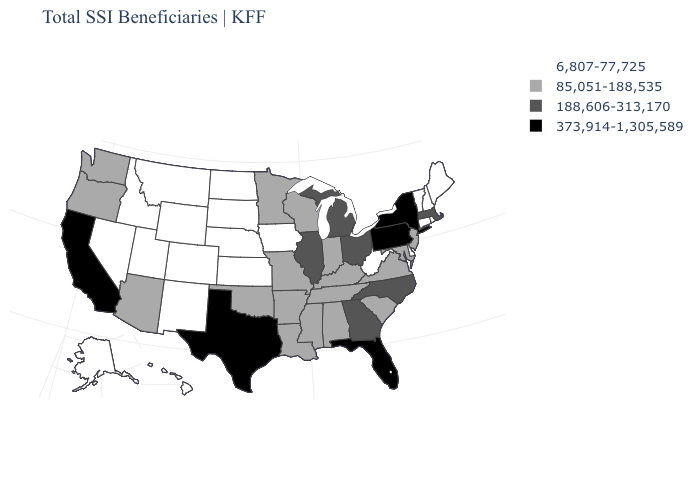Name the states that have a value in the range 85,051-188,535?
Short answer required. Alabama, Arizona, Arkansas, Indiana, Kentucky, Louisiana, Maryland, Minnesota, Mississippi, Missouri, New Jersey, Oklahoma, Oregon, South Carolina, Tennessee, Virginia, Washington, Wisconsin. Does the map have missing data?
Write a very short answer. No. Among the states that border New Hampshire , does Vermont have the highest value?
Concise answer only. No. Name the states that have a value in the range 6,807-77,725?
Concise answer only. Alaska, Colorado, Connecticut, Delaware, Hawaii, Idaho, Iowa, Kansas, Maine, Montana, Nebraska, Nevada, New Hampshire, New Mexico, North Dakota, Rhode Island, South Dakota, Utah, Vermont, West Virginia, Wyoming. Which states have the lowest value in the USA?
Answer briefly. Alaska, Colorado, Connecticut, Delaware, Hawaii, Idaho, Iowa, Kansas, Maine, Montana, Nebraska, Nevada, New Hampshire, New Mexico, North Dakota, Rhode Island, South Dakota, Utah, Vermont, West Virginia, Wyoming. Does South Dakota have a lower value than Illinois?
Answer briefly. Yes. Does the map have missing data?
Concise answer only. No. What is the lowest value in the USA?
Quick response, please. 6,807-77,725. How many symbols are there in the legend?
Be succinct. 4. Among the states that border California , which have the lowest value?
Concise answer only. Nevada. What is the highest value in the USA?
Concise answer only. 373,914-1,305,589. What is the highest value in states that border Maine?
Short answer required. 6,807-77,725. Name the states that have a value in the range 188,606-313,170?
Be succinct. Georgia, Illinois, Massachusetts, Michigan, North Carolina, Ohio. Name the states that have a value in the range 373,914-1,305,589?
Short answer required. California, Florida, New York, Pennsylvania, Texas. 